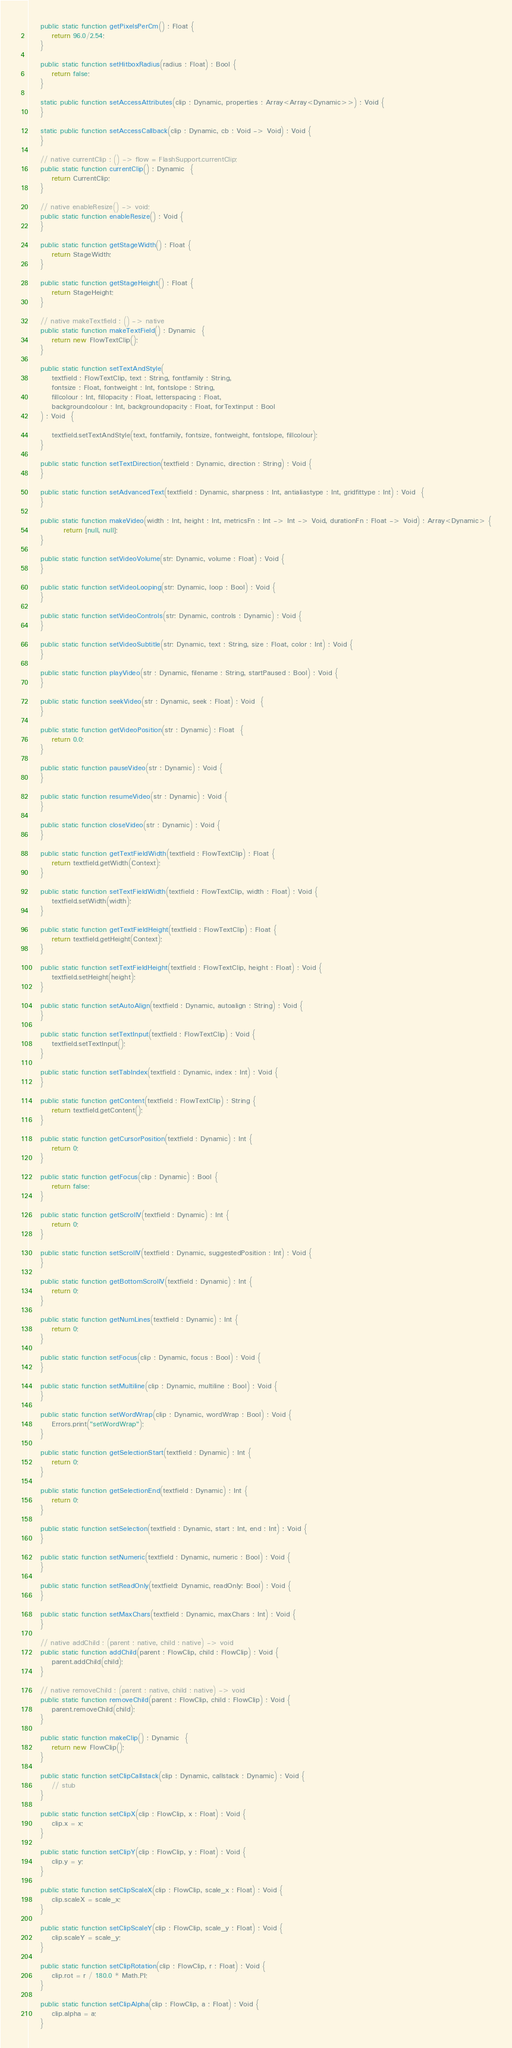<code> <loc_0><loc_0><loc_500><loc_500><_Haxe_>	public static function getPixelsPerCm() : Float {
		return 96.0/2.54;
	}

	public static function setHitboxRadius(radius : Float) : Bool {
		return false;
	}

	static public function setAccessAttributes(clip : Dynamic, properties : Array<Array<Dynamic>>) : Void {
	}

	static public function setAccessCallback(clip : Dynamic, cb : Void -> Void) : Void {
	}

	// native currentClip : () -> flow = FlashSupport.currentClip;
	public static function currentClip() : Dynamic  {
		return CurrentClip;
	}

	// native enableResize() -> void;
	public static function enableResize() : Void {
	}

	public static function getStageWidth() : Float {
		return StageWidth;
	}

	public static function getStageHeight() : Float {
		return StageHeight;
	}

	// native makeTextfield : () -> native
	public static function makeTextField() : Dynamic  {
		return new FlowTextClip();
	}

	public static function setTextAndStyle(
		textfield : FlowTextClip, text : String, fontfamily : String,
		fontsize : Float, fontweight : Int, fontslope : String,
		fillcolour : Int, fillopacity : Float, letterspacing : Float,
		backgroundcolour : Int, backgroundopacity : Float, forTextinput : Bool
	) : Void  {

		textfield.setTextAndStyle(text, fontfamily, fontsize, fontweight, fontslope, fillcolour);
	}

	public static function setTextDirection(textfield : Dynamic, direction : String) : Void {
	}

	public static function setAdvancedText(textfield : Dynamic, sharpness : Int, antialiastype : Int, gridfittype : Int) : Void  {
	}

	public static function makeVideo(width : Int, height : Int, metricsFn : Int -> Int -> Void, durationFn : Float -> Void) : Array<Dynamic> {
			return [null, null];
	}

	public static function setVideoVolume(str: Dynamic, volume : Float) : Void {
	}

	public static function setVideoLooping(str: Dynamic, loop : Bool) : Void {
	}

	public static function setVideoControls(str: Dynamic, controls : Dynamic) : Void {
	}

	public static function setVideoSubtitle(str: Dynamic, text : String, size : Float, color : Int) : Void {
	}

	public static function playVideo(str : Dynamic, filename : String, startPaused : Bool) : Void {
	}

	public static function seekVideo(str : Dynamic, seek : Float) : Void  {
	}

	public static function getVideoPosition(str : Dynamic) : Float  {
		return 0.0;
	}

	public static function pauseVideo(str : Dynamic) : Void {
	}

	public static function resumeVideo(str : Dynamic) : Void {
	}

	public static function closeVideo(str : Dynamic) : Void {
	}

	public static function getTextFieldWidth(textfield : FlowTextClip) : Float {
		return textfield.getWidth(Context);
	}

	public static function setTextFieldWidth(textfield : FlowTextClip, width : Float) : Void {
		textfield.setWidth(width);
	}

	public static function getTextFieldHeight(textfield : FlowTextClip) : Float {
		return textfield.getHeight(Context);
	}

	public static function setTextFieldHeight(textfield : FlowTextClip, height : Float) : Void {
		textfield.setHeight(height);
	}

	public static function setAutoAlign(textfield : Dynamic, autoalign : String) : Void {
	}

	public static function setTextInput(textfield : FlowTextClip) : Void {
		textfield.setTextInput();
	}

	public static function setTabIndex(textfield : Dynamic, index : Int) : Void {
	}

	public static function getContent(textfield : FlowTextClip) : String {
		return textfield.getContent();
	}

	public static function getCursorPosition(textfield : Dynamic) : Int {
		return 0;
	}

	public static function getFocus(clip : Dynamic) : Bool {
		return false;
	}

	public static function getScrollV(textfield : Dynamic) : Int {
		return 0;
	}

    public static function setScrollV(textfield : Dynamic, suggestedPosition : Int) : Void {
	}

	public static function getBottomScrollV(textfield : Dynamic) : Int {
		return 0;
	}

	public static function getNumLines(textfield : Dynamic) : Int {
		return 0;
	}

	public static function setFocus(clip : Dynamic, focus : Bool) : Void {
	}

	public static function setMultiline(clip : Dynamic, multiline : Bool) : Void {
	}

	public static function setWordWrap(clip : Dynamic, wordWrap : Bool) : Void {
		Errors.print("setWordWrap");
	}

	public static function getSelectionStart(textfield : Dynamic) : Int {
		return 0;
	}

	public static function getSelectionEnd(textfield : Dynamic) : Int {
		return 0;
	}

	public static function setSelection(textfield : Dynamic, start : Int, end : Int) : Void {
	}

	public static function setNumeric(textfield : Dynamic, numeric : Bool) : Void {
	}

	public static function setReadOnly(textfield: Dynamic, readOnly: Bool) : Void {
	}

	public static function setMaxChars(textfield : Dynamic, maxChars : Int) : Void {
	}

	// native addChild : (parent : native, child : native) -> void
	public static function addChild(parent : FlowClip, child : FlowClip) : Void {
		parent.addChild(child);
	}

	// native removeChild : (parent : native, child : native) -> void
	public static function removeChild(parent : FlowClip, child : FlowClip) : Void {
		parent.removeChild(child);
	}

	public static function makeClip() : Dynamic  {
		return new FlowClip();
	}

    public static function setClipCallstack(clip : Dynamic, callstack : Dynamic) : Void {
        // stub
    }

	public static function setClipX(clip : FlowClip, x : Float) : Void {
		clip.x = x;
	}

	public static function setClipY(clip : FlowClip, y : Float) : Void {
		clip.y = y;
	}

	public static function setClipScaleX(clip : FlowClip, scale_x : Float) : Void {
		clip.scaleX = scale_x;
	}

	public static function setClipScaleY(clip : FlowClip, scale_y : Float) : Void {
		clip.scaleY = scale_y;
	}

	public static function setClipRotation(clip : FlowClip, r : Float) : Void {
		clip.rot = r / 180.0 * Math.PI;
	}

	public static function setClipAlpha(clip : FlowClip, a : Float) : Void {
		clip.alpha = a;
	}
</code> 